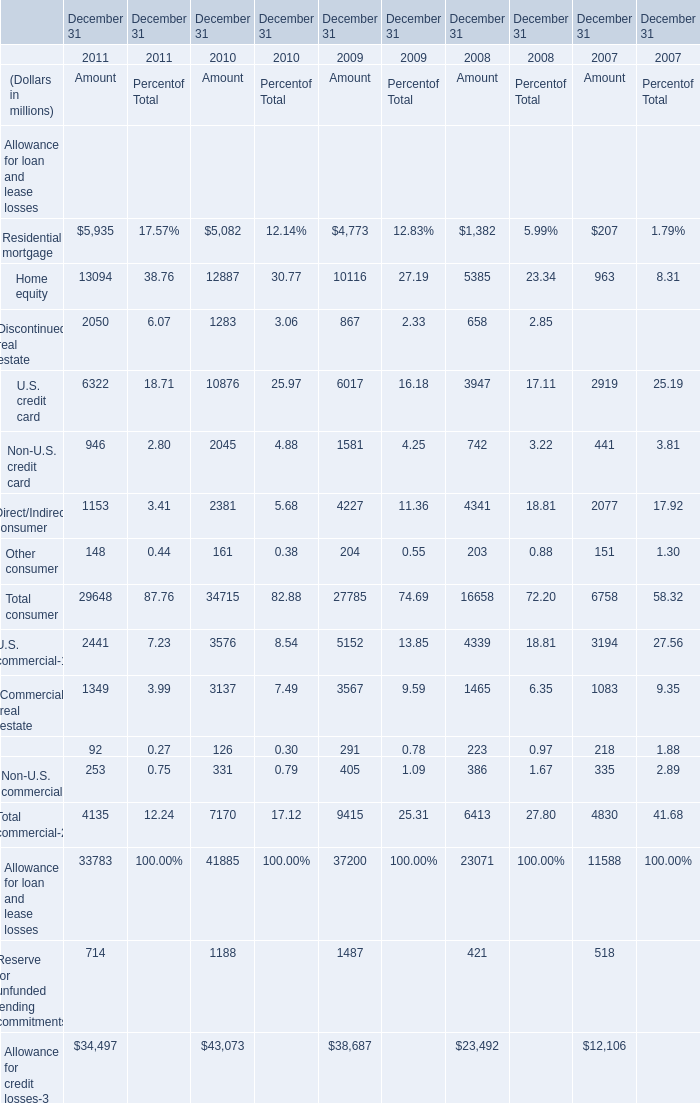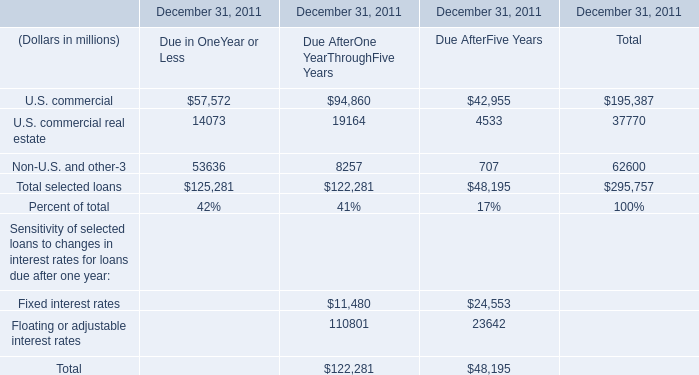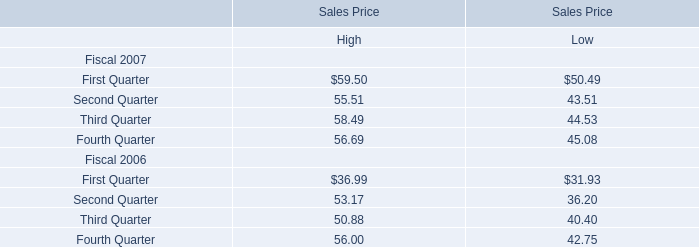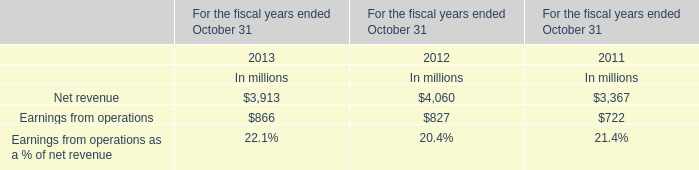What is the ratio of Home equity for Amount to the Third Quarter for High in 2007? 
Computations: (963 / 58.49)
Answer: 16.46435. 